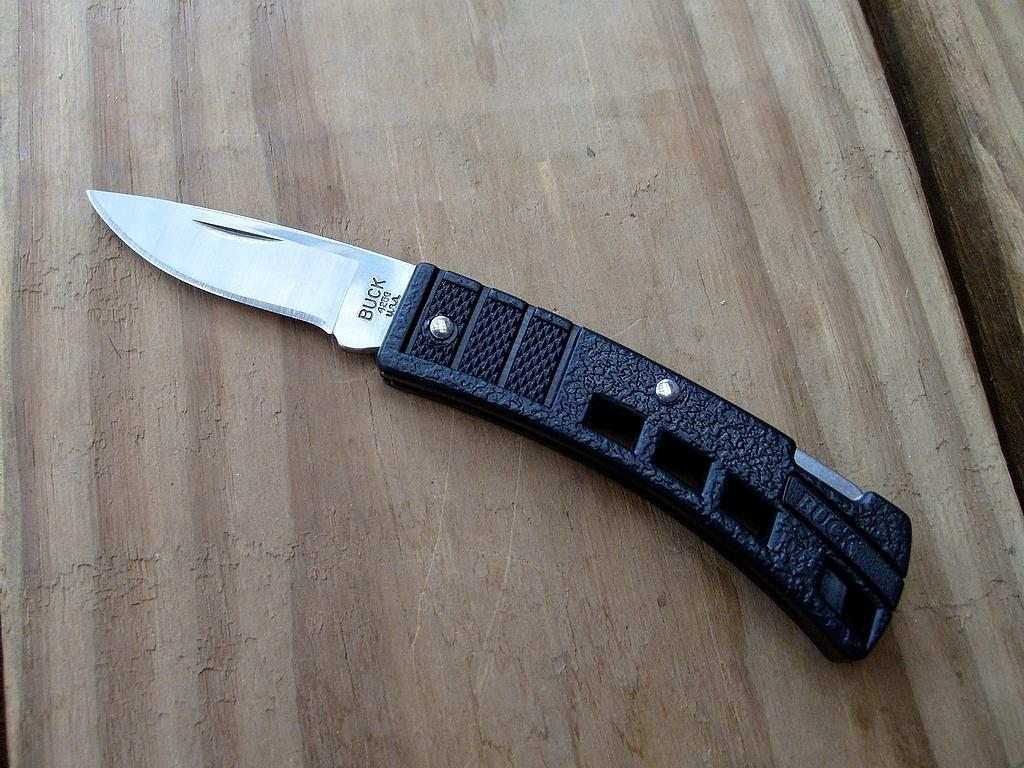What object is present in the image that is typically used for cutting? There is a knife in the image. What material is the object the knife is placed on? The knife is on a wooden object. What type of collar is visible on the pie in the image? There is no pie or collar present in the image; it only features a knife on a wooden object. 